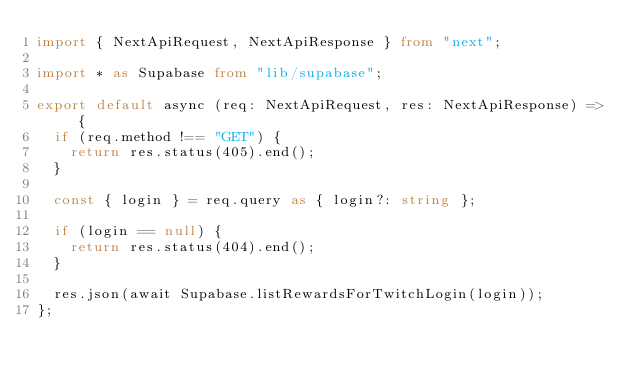<code> <loc_0><loc_0><loc_500><loc_500><_TypeScript_>import { NextApiRequest, NextApiResponse } from "next";

import * as Supabase from "lib/supabase";

export default async (req: NextApiRequest, res: NextApiResponse) => {
  if (req.method !== "GET") {
    return res.status(405).end();
  }

  const { login } = req.query as { login?: string };

  if (login == null) {
    return res.status(404).end();
  }

  res.json(await Supabase.listRewardsForTwitchLogin(login));
};
</code> 